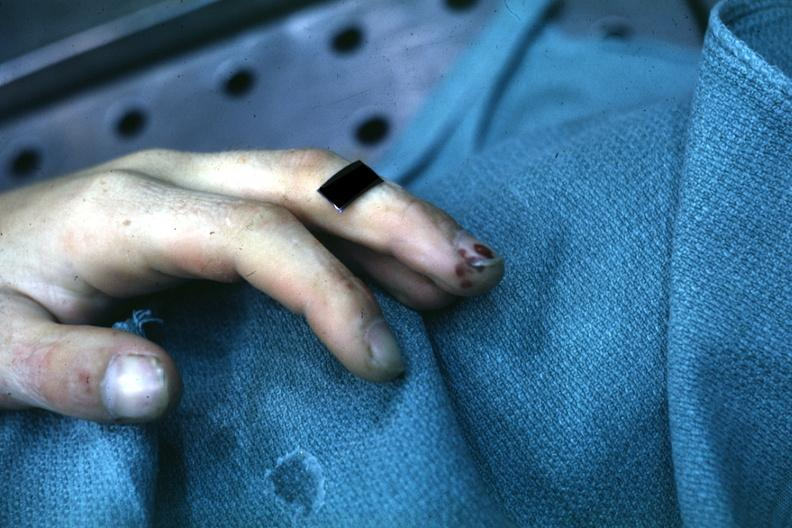re nipples present?
Answer the question using a single word or phrase. No 